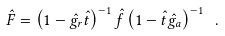<formula> <loc_0><loc_0><loc_500><loc_500>\hat { F } = \left ( 1 - \hat { g _ { r } } \hat { t } \right ) ^ { - 1 } \hat { f } \left ( 1 - \hat { t } \hat { g _ { a } } \right ) ^ { - 1 } \ .</formula> 